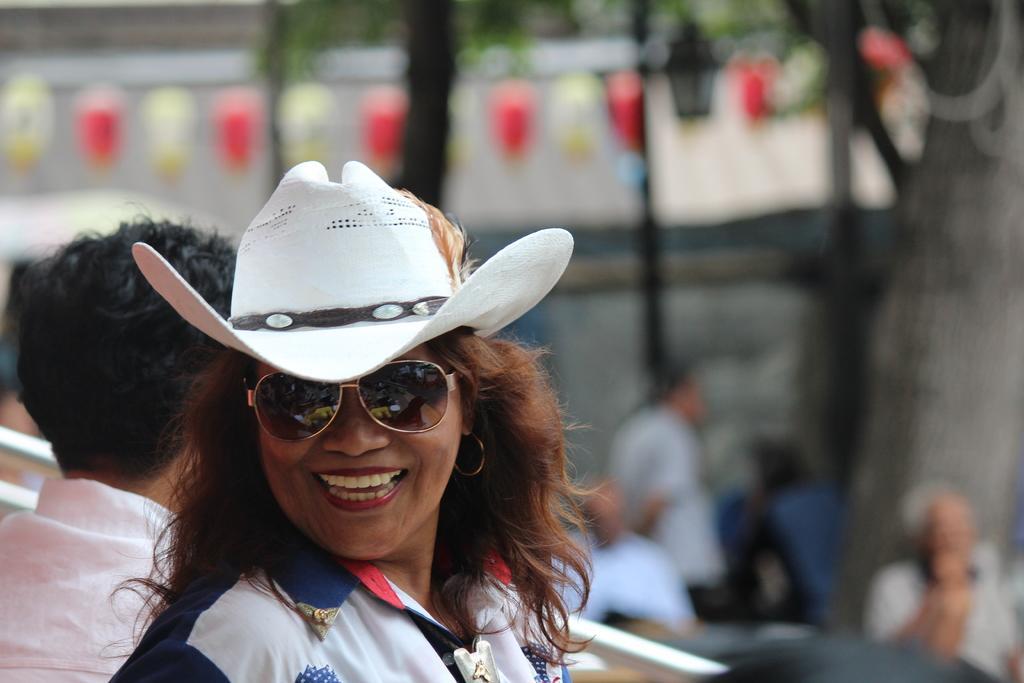How would you summarize this image in a sentence or two? In this image there is women she is wearing white hat and smiling to a photograph behind her there is men he is wearing white color shirt, in the right side there few persons sitting on chairs, in the background is blurry. 